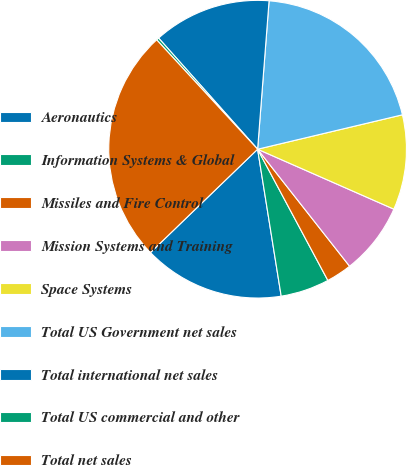<chart> <loc_0><loc_0><loc_500><loc_500><pie_chart><fcel>Aeronautics<fcel>Information Systems & Global<fcel>Missiles and Fire Control<fcel>Mission Systems and Training<fcel>Space Systems<fcel>Total US Government net sales<fcel>Total international net sales<fcel>Total US commercial and other<fcel>Total net sales<nl><fcel>15.32%<fcel>5.29%<fcel>2.78%<fcel>7.8%<fcel>10.31%<fcel>20.06%<fcel>12.81%<fcel>0.28%<fcel>25.35%<nl></chart> 